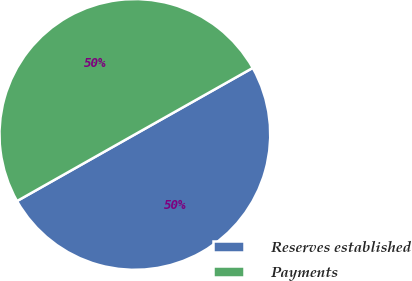<chart> <loc_0><loc_0><loc_500><loc_500><pie_chart><fcel>Reserves established<fcel>Payments<nl><fcel>49.99%<fcel>50.01%<nl></chart> 